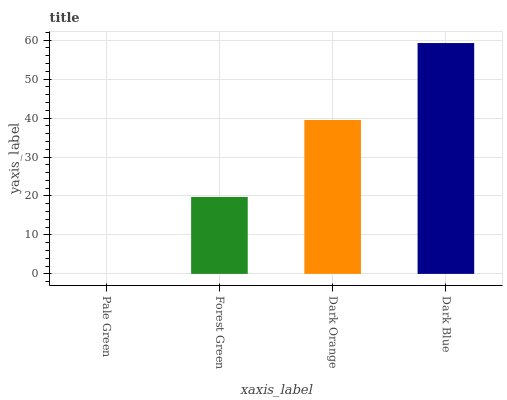Is Forest Green the minimum?
Answer yes or no. No. Is Forest Green the maximum?
Answer yes or no. No. Is Forest Green greater than Pale Green?
Answer yes or no. Yes. Is Pale Green less than Forest Green?
Answer yes or no. Yes. Is Pale Green greater than Forest Green?
Answer yes or no. No. Is Forest Green less than Pale Green?
Answer yes or no. No. Is Dark Orange the high median?
Answer yes or no. Yes. Is Forest Green the low median?
Answer yes or no. Yes. Is Dark Blue the high median?
Answer yes or no. No. Is Dark Orange the low median?
Answer yes or no. No. 